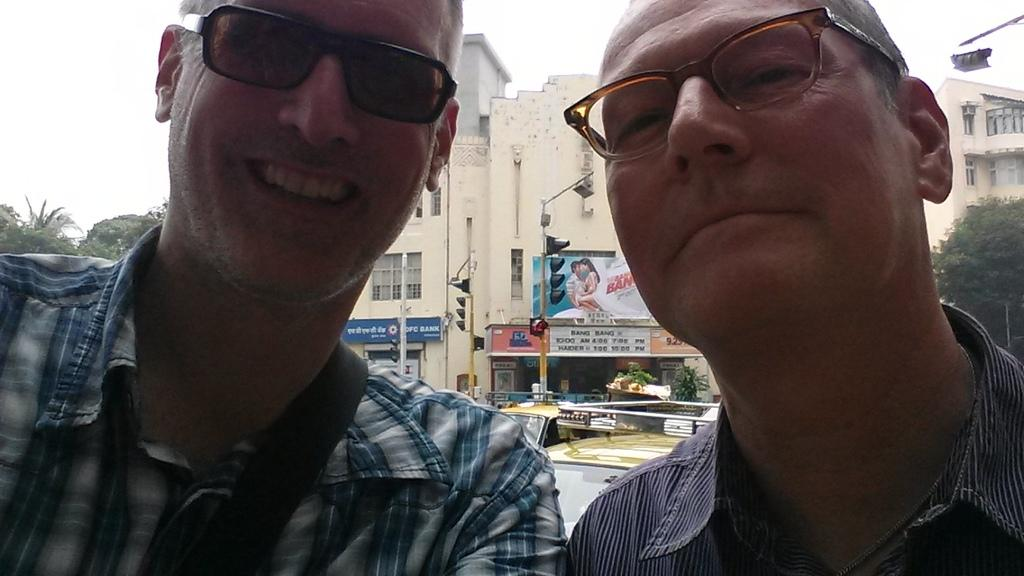How many men are present in the image? There are two men in the image. What are the men wearing that is visible in the image? The men are wearing spectacles. What can be seen in the background of the image? There are buildings, poles, traffic signals, boards, trees, vehicles, and the sky visible in the background of the image. What type of fiction is the men reading in the image? There is no fiction present in the image; the men are wearing spectacles, but there is no indication of them reading anything. Can you describe the beast that is interacting with the men in the image? There is no beast present in the image; the only subjects are the two men and the various elements visible in the background. 